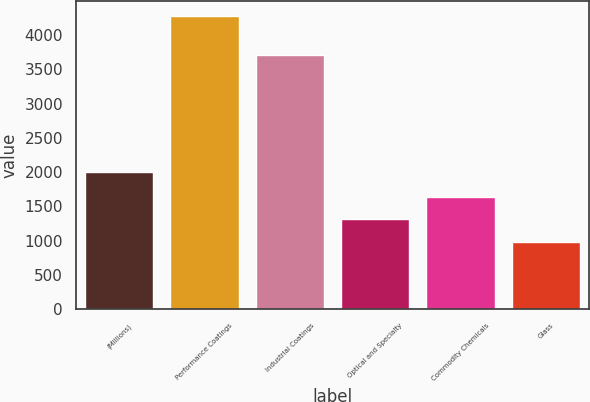Convert chart. <chart><loc_0><loc_0><loc_500><loc_500><bar_chart><fcel>(Millions)<fcel>Performance Coatings<fcel>Industrial Coatings<fcel>Optical and Specialty<fcel>Commodity Chemicals<fcel>Glass<nl><fcel>2010<fcel>4281<fcel>3708<fcel>1314.6<fcel>1644.2<fcel>985<nl></chart> 